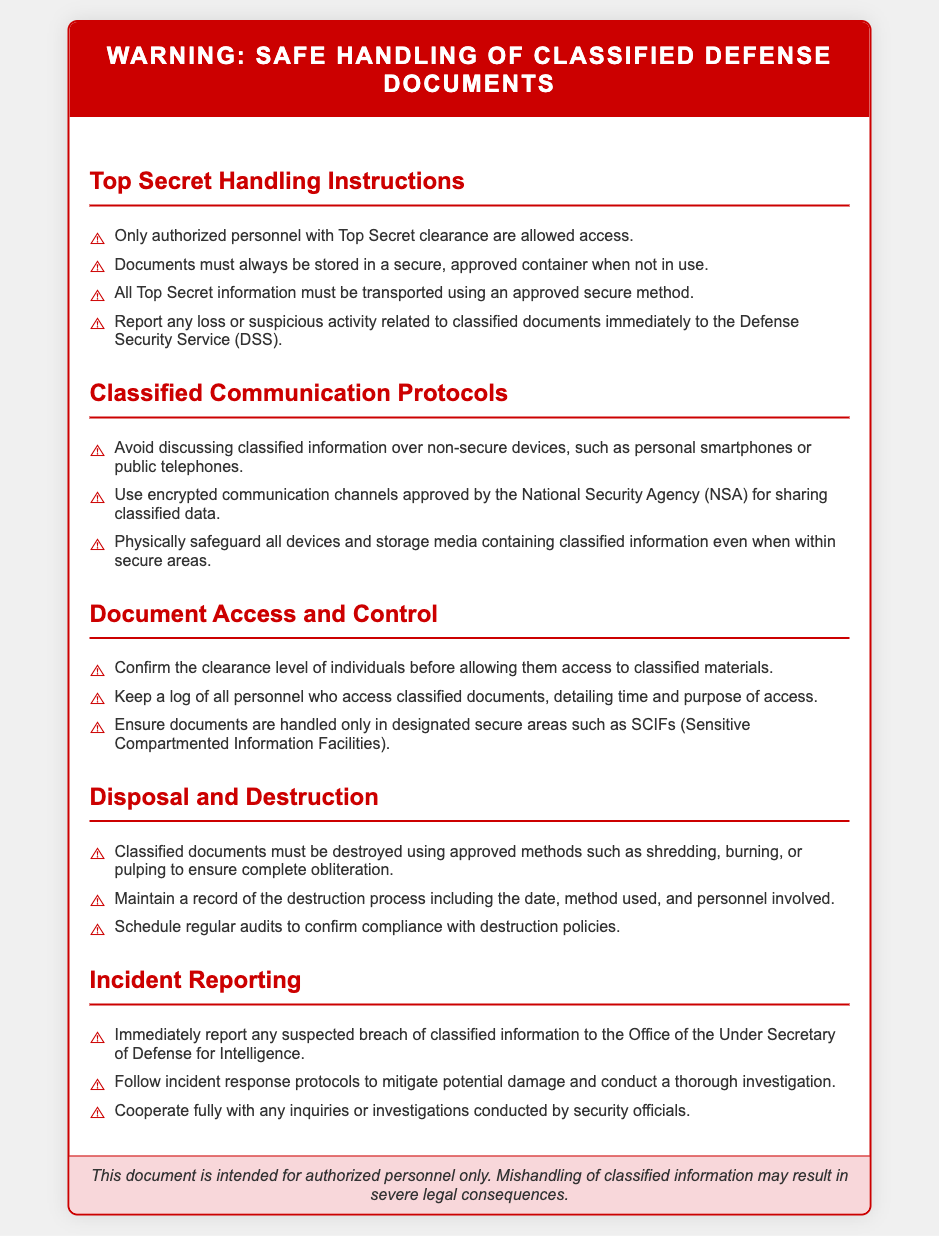What is the header title of the document? The header title is clearly stated at the beginning of the document, indicating the subject matter addressed.
Answer: Warning: Safe Handling of Classified Defense Documents Who is allowed access to Top Secret documents? The document specifies who is permitted to access classified materials based on clearance levels.
Answer: Authorized personnel with Top Secret clearance What should be done with lost classified documents? The document provides specific instructions on how to respond to incidents involving classified materials.
Answer: Report immediately to the Defense Security Service What type of communication devices should be avoided for discussing classified information? The document outlines which devices are not secure for discussing sensitive information.
Answer: Non-secure devices What is required to confirm access to classified materials? The document describes the necessary actions to take before granting access to classified documents.
Answer: Confirm the clearance level How must classified documents be destroyed? The document specifies the approved methods for disposing of classified materials securely.
Answer: Shredding, burning, or pulping Which facility type is mentioned for handling classified documents? The document refers to specific secure areas designated for managing classified information.
Answer: SCIFs What should be included in the destruction record? The document highlights essential details that should be maintained regarding the destruction of classified materials.
Answer: Date, method used, and personnel involved When should incidents of suspected breaches be reported? The document outlines when to take action in the event of a possible security breach.
Answer: Immediately 